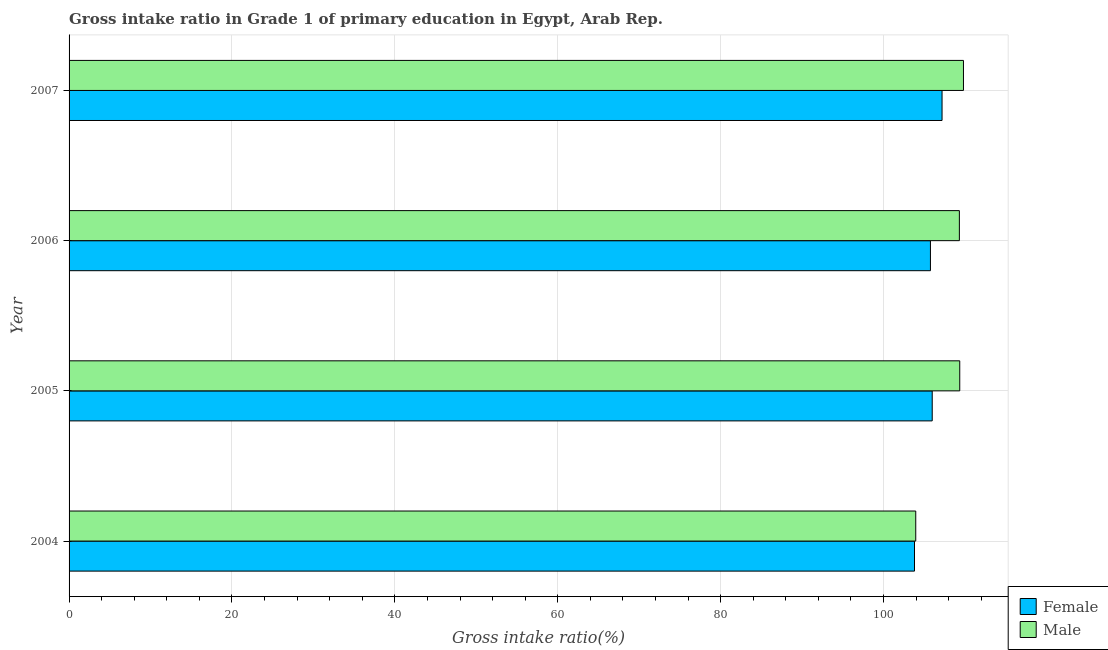How many bars are there on the 4th tick from the top?
Ensure brevity in your answer.  2. How many bars are there on the 4th tick from the bottom?
Provide a short and direct response. 2. In how many cases, is the number of bars for a given year not equal to the number of legend labels?
Ensure brevity in your answer.  0. What is the gross intake ratio(female) in 2005?
Ensure brevity in your answer.  105.97. Across all years, what is the maximum gross intake ratio(female)?
Offer a very short reply. 107.18. Across all years, what is the minimum gross intake ratio(male)?
Offer a terse response. 103.95. In which year was the gross intake ratio(male) maximum?
Ensure brevity in your answer.  2007. What is the total gross intake ratio(female) in the graph?
Make the answer very short. 422.71. What is the difference between the gross intake ratio(male) in 2004 and that in 2006?
Your answer should be very brief. -5.36. What is the difference between the gross intake ratio(male) in 2005 and the gross intake ratio(female) in 2007?
Offer a very short reply. 2.17. What is the average gross intake ratio(male) per year?
Offer a terse response. 108.11. In the year 2007, what is the difference between the gross intake ratio(female) and gross intake ratio(male)?
Your answer should be very brief. -2.63. What is the ratio of the gross intake ratio(female) in 2004 to that in 2005?
Your answer should be very brief. 0.98. What is the difference between the highest and the second highest gross intake ratio(female)?
Keep it short and to the point. 1.21. What is the difference between the highest and the lowest gross intake ratio(female)?
Offer a terse response. 3.38. In how many years, is the gross intake ratio(female) greater than the average gross intake ratio(female) taken over all years?
Make the answer very short. 3. What does the 2nd bar from the bottom in 2005 represents?
Offer a very short reply. Male. What is the difference between two consecutive major ticks on the X-axis?
Offer a very short reply. 20. Are the values on the major ticks of X-axis written in scientific E-notation?
Provide a short and direct response. No. Does the graph contain any zero values?
Your response must be concise. No. Does the graph contain grids?
Your response must be concise. Yes. Where does the legend appear in the graph?
Keep it short and to the point. Bottom right. How are the legend labels stacked?
Make the answer very short. Vertical. What is the title of the graph?
Give a very brief answer. Gross intake ratio in Grade 1 of primary education in Egypt, Arab Rep. What is the label or title of the X-axis?
Give a very brief answer. Gross intake ratio(%). What is the label or title of the Y-axis?
Provide a short and direct response. Year. What is the Gross intake ratio(%) of Female in 2004?
Offer a terse response. 103.8. What is the Gross intake ratio(%) in Male in 2004?
Give a very brief answer. 103.95. What is the Gross intake ratio(%) in Female in 2005?
Offer a very short reply. 105.97. What is the Gross intake ratio(%) in Male in 2005?
Provide a short and direct response. 109.35. What is the Gross intake ratio(%) in Female in 2006?
Provide a succinct answer. 105.75. What is the Gross intake ratio(%) of Male in 2006?
Give a very brief answer. 109.31. What is the Gross intake ratio(%) in Female in 2007?
Provide a succinct answer. 107.18. What is the Gross intake ratio(%) in Male in 2007?
Your answer should be compact. 109.81. Across all years, what is the maximum Gross intake ratio(%) in Female?
Your answer should be very brief. 107.18. Across all years, what is the maximum Gross intake ratio(%) in Male?
Provide a succinct answer. 109.81. Across all years, what is the minimum Gross intake ratio(%) of Female?
Give a very brief answer. 103.8. Across all years, what is the minimum Gross intake ratio(%) of Male?
Offer a terse response. 103.95. What is the total Gross intake ratio(%) in Female in the graph?
Make the answer very short. 422.71. What is the total Gross intake ratio(%) of Male in the graph?
Ensure brevity in your answer.  432.42. What is the difference between the Gross intake ratio(%) in Female in 2004 and that in 2005?
Keep it short and to the point. -2.18. What is the difference between the Gross intake ratio(%) in Male in 2004 and that in 2005?
Ensure brevity in your answer.  -5.4. What is the difference between the Gross intake ratio(%) in Female in 2004 and that in 2006?
Ensure brevity in your answer.  -1.96. What is the difference between the Gross intake ratio(%) in Male in 2004 and that in 2006?
Provide a succinct answer. -5.36. What is the difference between the Gross intake ratio(%) in Female in 2004 and that in 2007?
Offer a terse response. -3.38. What is the difference between the Gross intake ratio(%) in Male in 2004 and that in 2007?
Offer a terse response. -5.86. What is the difference between the Gross intake ratio(%) in Female in 2005 and that in 2006?
Your response must be concise. 0.22. What is the difference between the Gross intake ratio(%) in Male in 2005 and that in 2006?
Provide a succinct answer. 0.05. What is the difference between the Gross intake ratio(%) in Female in 2005 and that in 2007?
Provide a short and direct response. -1.21. What is the difference between the Gross intake ratio(%) of Male in 2005 and that in 2007?
Offer a terse response. -0.46. What is the difference between the Gross intake ratio(%) of Female in 2006 and that in 2007?
Provide a succinct answer. -1.43. What is the difference between the Gross intake ratio(%) in Male in 2006 and that in 2007?
Keep it short and to the point. -0.5. What is the difference between the Gross intake ratio(%) in Female in 2004 and the Gross intake ratio(%) in Male in 2005?
Make the answer very short. -5.56. What is the difference between the Gross intake ratio(%) in Female in 2004 and the Gross intake ratio(%) in Male in 2006?
Your response must be concise. -5.51. What is the difference between the Gross intake ratio(%) in Female in 2004 and the Gross intake ratio(%) in Male in 2007?
Make the answer very short. -6.01. What is the difference between the Gross intake ratio(%) of Female in 2005 and the Gross intake ratio(%) of Male in 2006?
Give a very brief answer. -3.33. What is the difference between the Gross intake ratio(%) in Female in 2005 and the Gross intake ratio(%) in Male in 2007?
Give a very brief answer. -3.84. What is the difference between the Gross intake ratio(%) in Female in 2006 and the Gross intake ratio(%) in Male in 2007?
Your answer should be compact. -4.06. What is the average Gross intake ratio(%) in Female per year?
Keep it short and to the point. 105.68. What is the average Gross intake ratio(%) in Male per year?
Offer a very short reply. 108.11. In the year 2004, what is the difference between the Gross intake ratio(%) of Female and Gross intake ratio(%) of Male?
Give a very brief answer. -0.15. In the year 2005, what is the difference between the Gross intake ratio(%) in Female and Gross intake ratio(%) in Male?
Give a very brief answer. -3.38. In the year 2006, what is the difference between the Gross intake ratio(%) of Female and Gross intake ratio(%) of Male?
Provide a succinct answer. -3.55. In the year 2007, what is the difference between the Gross intake ratio(%) in Female and Gross intake ratio(%) in Male?
Offer a terse response. -2.63. What is the ratio of the Gross intake ratio(%) of Female in 2004 to that in 2005?
Provide a short and direct response. 0.98. What is the ratio of the Gross intake ratio(%) of Male in 2004 to that in 2005?
Your response must be concise. 0.95. What is the ratio of the Gross intake ratio(%) in Female in 2004 to that in 2006?
Offer a terse response. 0.98. What is the ratio of the Gross intake ratio(%) in Male in 2004 to that in 2006?
Ensure brevity in your answer.  0.95. What is the ratio of the Gross intake ratio(%) in Female in 2004 to that in 2007?
Your answer should be very brief. 0.97. What is the ratio of the Gross intake ratio(%) of Male in 2004 to that in 2007?
Your answer should be compact. 0.95. What is the ratio of the Gross intake ratio(%) in Female in 2005 to that in 2006?
Your answer should be very brief. 1. What is the ratio of the Gross intake ratio(%) of Female in 2005 to that in 2007?
Offer a very short reply. 0.99. What is the ratio of the Gross intake ratio(%) of Male in 2005 to that in 2007?
Ensure brevity in your answer.  1. What is the ratio of the Gross intake ratio(%) of Female in 2006 to that in 2007?
Offer a very short reply. 0.99. What is the difference between the highest and the second highest Gross intake ratio(%) in Female?
Offer a terse response. 1.21. What is the difference between the highest and the second highest Gross intake ratio(%) of Male?
Ensure brevity in your answer.  0.46. What is the difference between the highest and the lowest Gross intake ratio(%) in Female?
Make the answer very short. 3.38. What is the difference between the highest and the lowest Gross intake ratio(%) in Male?
Make the answer very short. 5.86. 